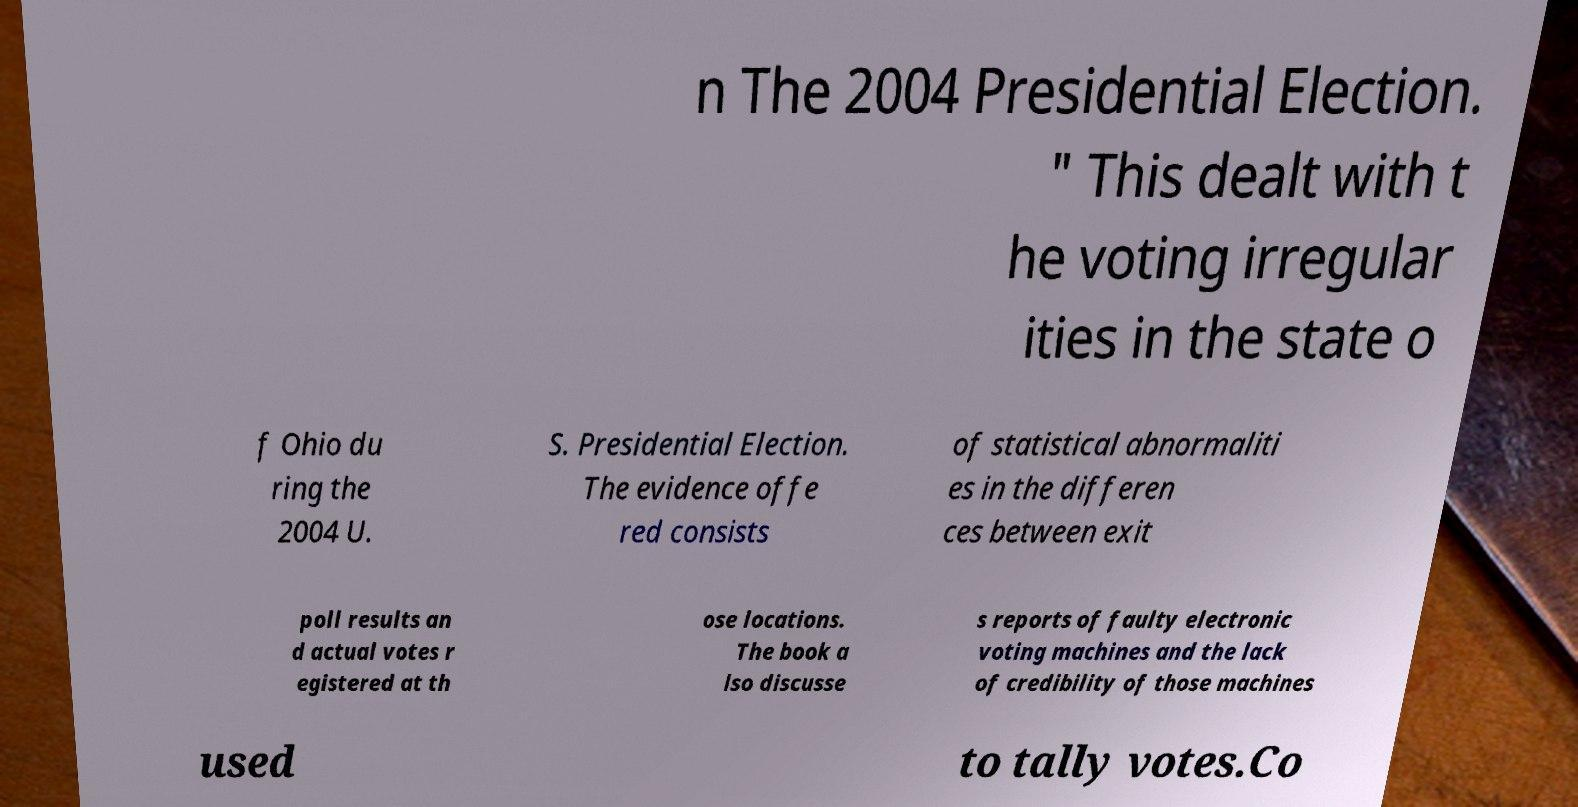Please read and relay the text visible in this image. What does it say? n The 2004 Presidential Election. " This dealt with t he voting irregular ities in the state o f Ohio du ring the 2004 U. S. Presidential Election. The evidence offe red consists of statistical abnormaliti es in the differen ces between exit poll results an d actual votes r egistered at th ose locations. The book a lso discusse s reports of faulty electronic voting machines and the lack of credibility of those machines used to tally votes.Co 